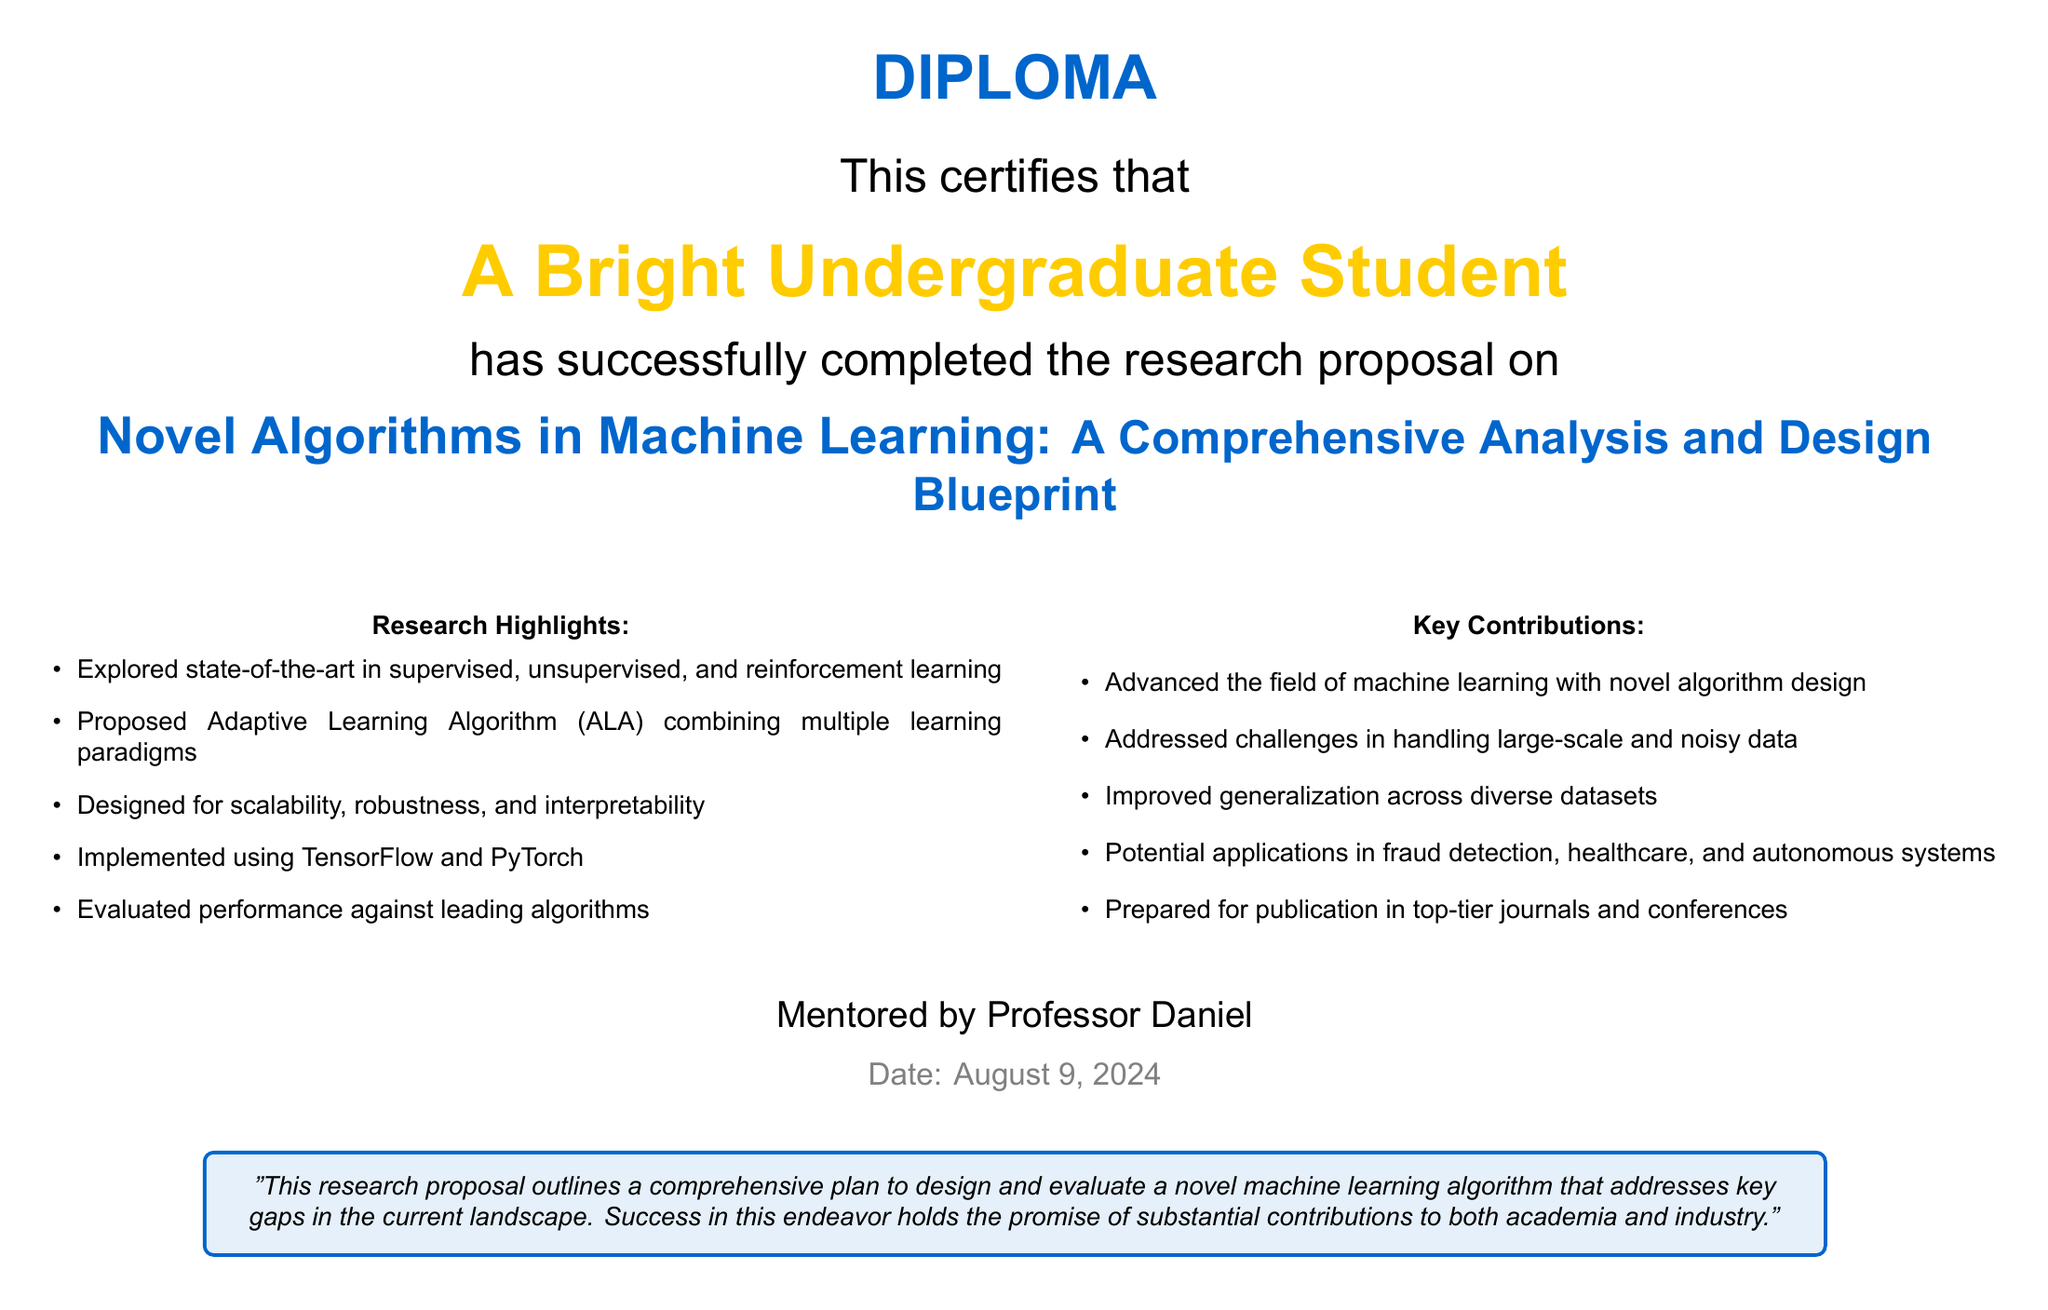what is the title of the research proposal? The title of the research proposal is presented prominently in the document, which is "Novel Algorithms in Machine Learning: A Comprehensive Analysis and Design Blueprint."
Answer: Novel Algorithms in Machine Learning: A Comprehensive Analysis and Design Blueprint who mentored the student? The document states that the student was mentored by Professor Daniel.
Answer: Professor Daniel what programming frameworks were used for implementation? The document mentions that the implementation was done using TensorFlow and PyTorch.
Answer: TensorFlow and PyTorch what is one application area mentioned for the proposed algorithm? The document lists potential applications, and one of them mentioned is fraud detection.
Answer: fraud detection how many key contributions are listed in the document? The document includes a bullet point list of contributions, specifically stating five key contributions.
Answer: five what does ALA stand for in the proposal? The acronym ALA in the context of the document refers to the proposed Adaptive Learning Algorithm.
Answer: Adaptive Learning Algorithm when was the diploma issued? The document indicates the date of issue as today’s date, which is represented as "\today" in the code.
Answer: today's date 